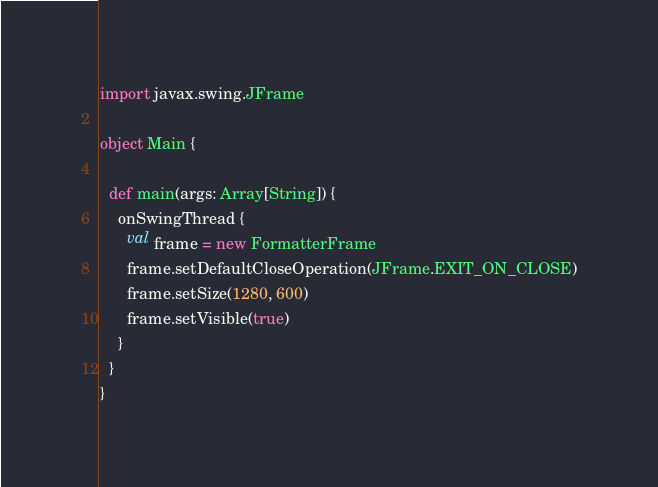<code> <loc_0><loc_0><loc_500><loc_500><_Scala_>import javax.swing.JFrame

object Main {

  def main(args: Array[String]) {
    onSwingThread {
      val frame = new FormatterFrame
      frame.setDefaultCloseOperation(JFrame.EXIT_ON_CLOSE)
      frame.setSize(1280, 600)
      frame.setVisible(true)
    }
  }
}</code> 